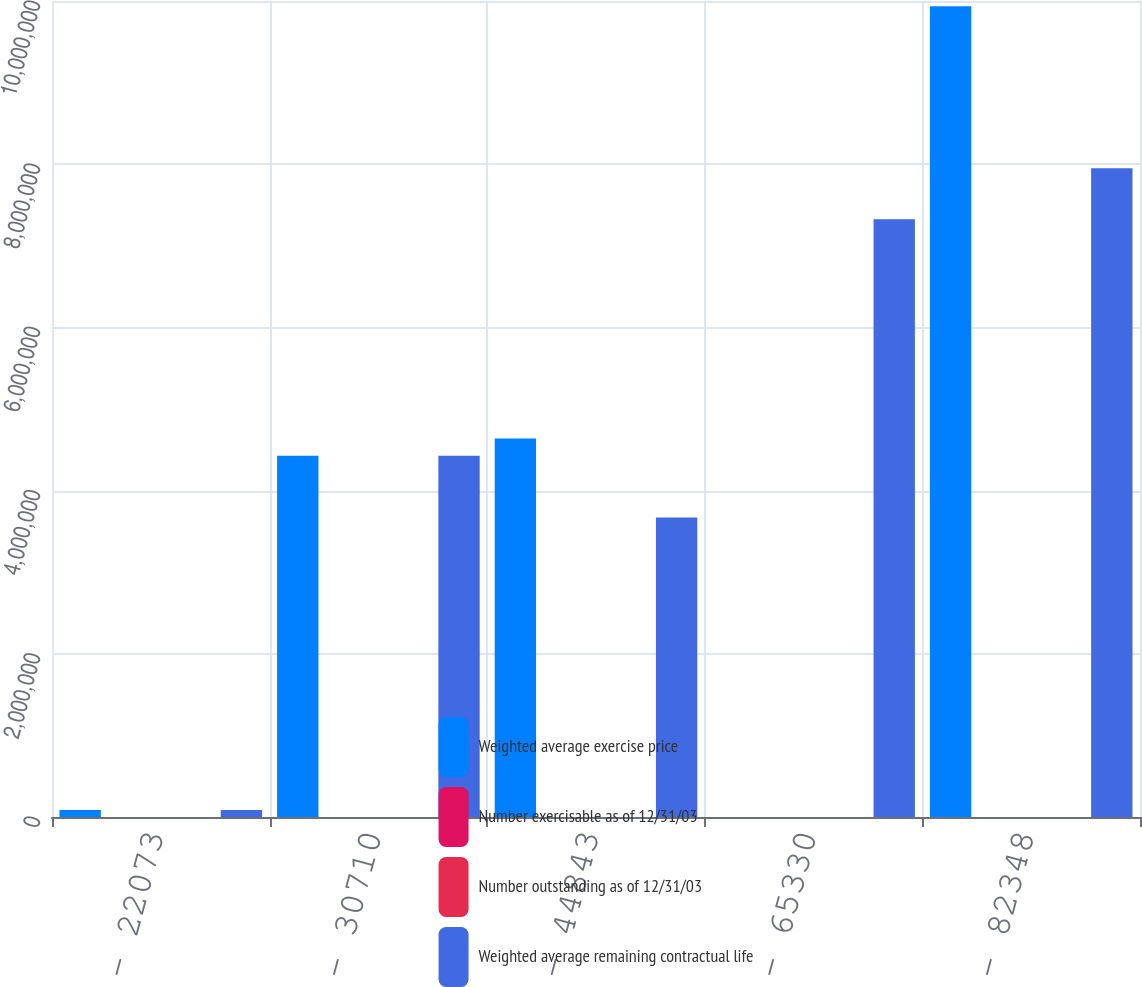Convert chart to OTSL. <chart><loc_0><loc_0><loc_500><loc_500><stacked_bar_chart><ecel><fcel>3831 - 22073<fcel>24142 - 30710<fcel>30795 - 44843<fcel>46020 - 65330<fcel>71315 - 82348<nl><fcel>Weighted average exercise price<fcel>86503<fcel>4.42662e+06<fcel>4.63775e+06<fcel>80.64<fcel>9.93539e+06<nl><fcel>Number exercisable as of 12/31/03<fcel>1.83<fcel>1.39<fcel>3.94<fcel>7.39<fcel>5.28<nl><fcel>Number outstanding as of 12/31/03<fcel>19.66<fcel>27.62<fcel>39.62<fcel>54.84<fcel>80.64<nl><fcel>Weighted average remaining contractual life<fcel>86503<fcel>4.42662e+06<fcel>3.67185e+06<fcel>7.32684e+06<fcel>7.94894e+06<nl></chart> 